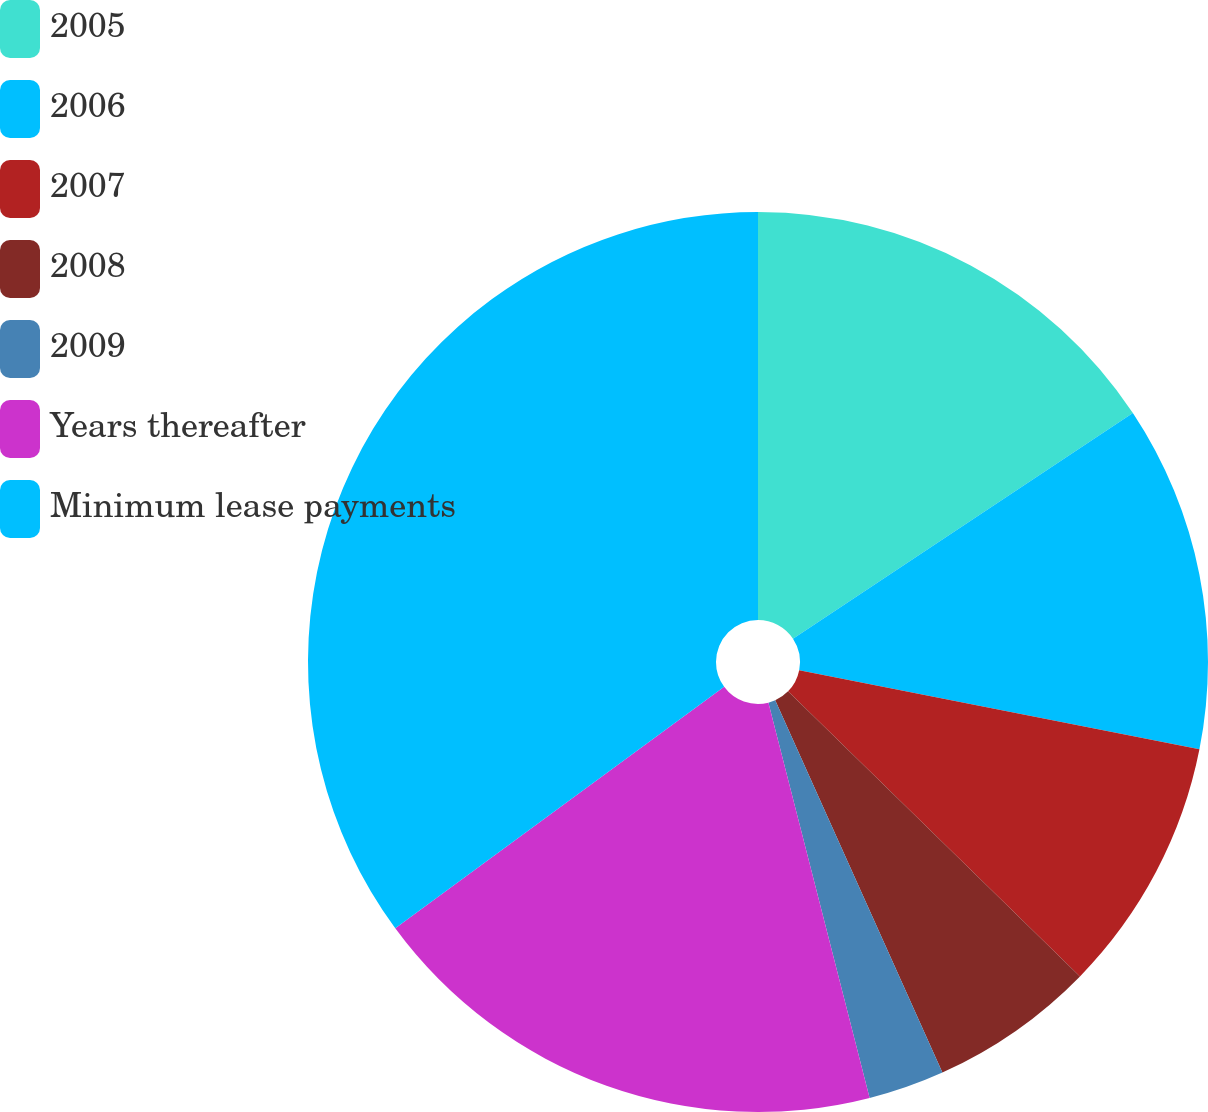Convert chart to OTSL. <chart><loc_0><loc_0><loc_500><loc_500><pie_chart><fcel>2005<fcel>2006<fcel>2007<fcel>2008<fcel>2009<fcel>Years thereafter<fcel>Minimum lease payments<nl><fcel>15.67%<fcel>12.44%<fcel>9.2%<fcel>5.97%<fcel>2.73%<fcel>18.91%<fcel>35.08%<nl></chart> 